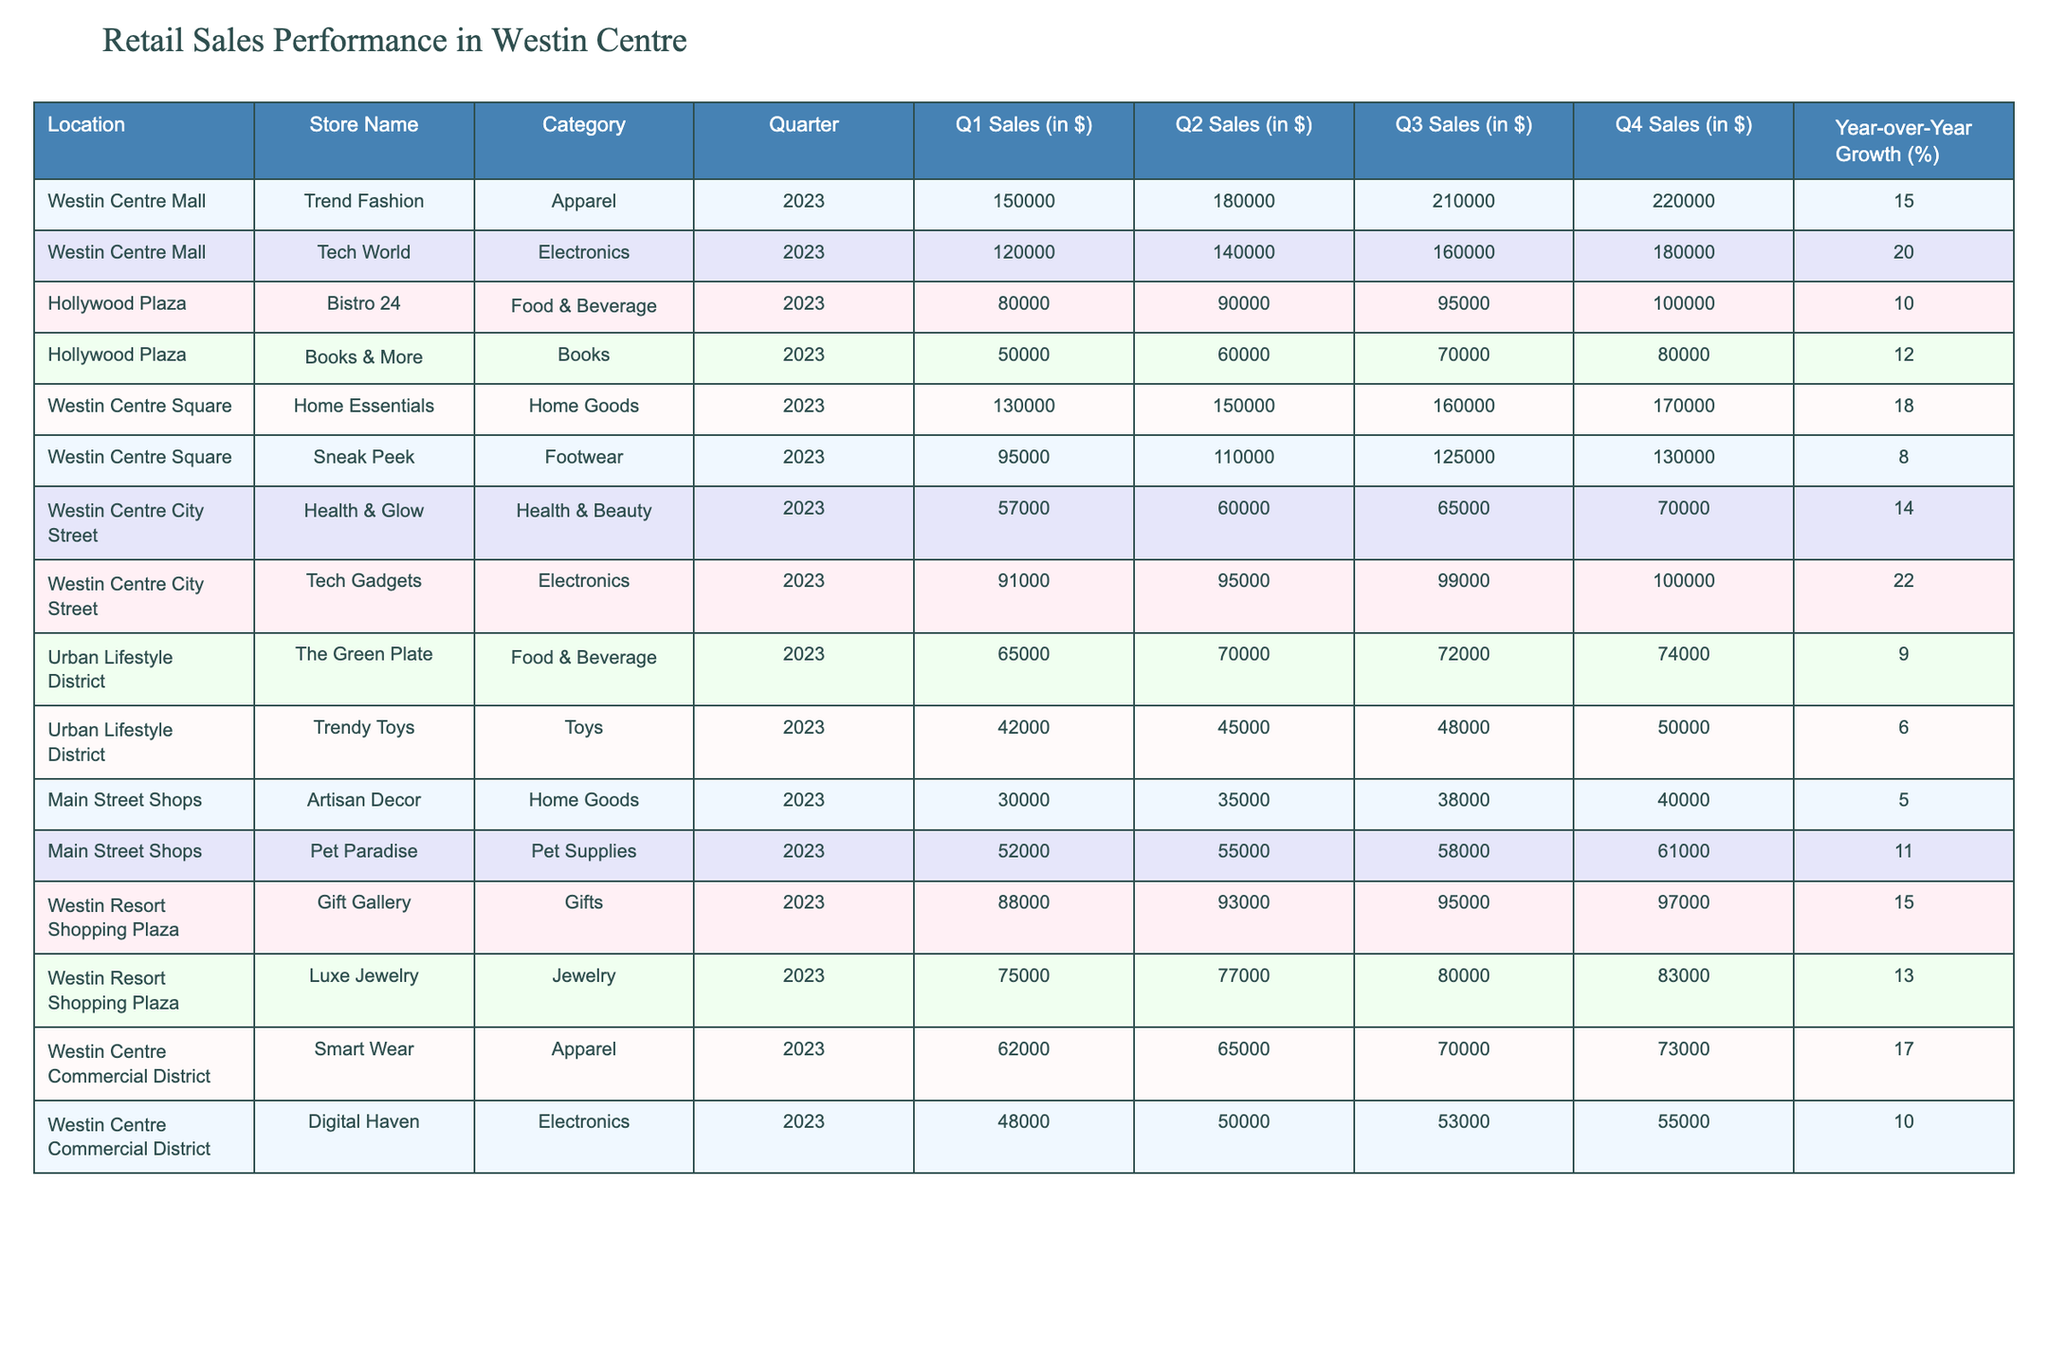What were the Q1 sales of Trend Fashion in 2023? By locating the row for Trend Fashion in the table and checking the Q1 Sales column, we see the value is 150000.
Answer: 150000 Which store had the highest Year-over-Year Growth percentage in 2023? Reviewing the Year-over-Year Growth column, Tech World shows the highest value of 20%.
Answer: Tech World What is the total Q4 sales of Food & Beverage stores in 2023? The Q4 sales of Food & Beverage stores are Bistro 24 (100000) and The Green Plate (74000), so the total is 100000 + 74000 = 174000.
Answer: 174000 Is the Year-over-Year Growth of Home Essentials greater than 15%? Home Essentials has a Year-over-Year Growth of 18%, which is indeed greater than 15%.
Answer: Yes What is the average Q2 sales of Apparel stores in 2023? The Q2 Sales for Trend Fashion is 180000 and Smart Wear is 65000. The sum is 180000 + 65000 = 245000. There are 2 apparel stores, so the average is 245000 / 2 = 122500.
Answer: 122500 Which shopping district contains the store with the lowest Q3 sales in 2023? By checking the Q3 sales across all stores, Trendy Toys in the Urban Lifestyle District has the lowest at 48000.
Answer: Urban Lifestyle District What was the Q1 sales figure for Tech Gadgets? The row for Tech Gadgets shows a Q1 sales value of 91000 in 2023.
Answer: 91000 How much more did Luxe Jewelry earn in Q1 compared to Pet Paradise? Luxe Jewelry earned 75000 and Pet Paradise earned 52000 in Q1, so the difference is 75000 - 52000 = 23000.
Answer: 23000 What percentage growth did Digital Haven experience from Q1 to Q4 in 2023? Digital Haven’s Q1 sales were 48000 and Q4 sales were 55000. The growth is calculated as ((55000 - 48000) / 48000) * 100 ≈ 14.58%.
Answer: Approximately 14.58% Did Health & Glow reach more than 70000 in Q4 sales? Health & Glow had Q4 sales of 70000, which does reach that number, but does not exceed it.
Answer: No Which store showed a decrease in sales from Q2 to Q3? Checking the rows, Sneak Peek shows a Q2 sales of 110000 and Q3 sales of 125000, which is an increase. All stores show growth or stability, but Trendy Toys increased its Q3 sales from 45000 to 48000.
Answer: None showed a decrease 